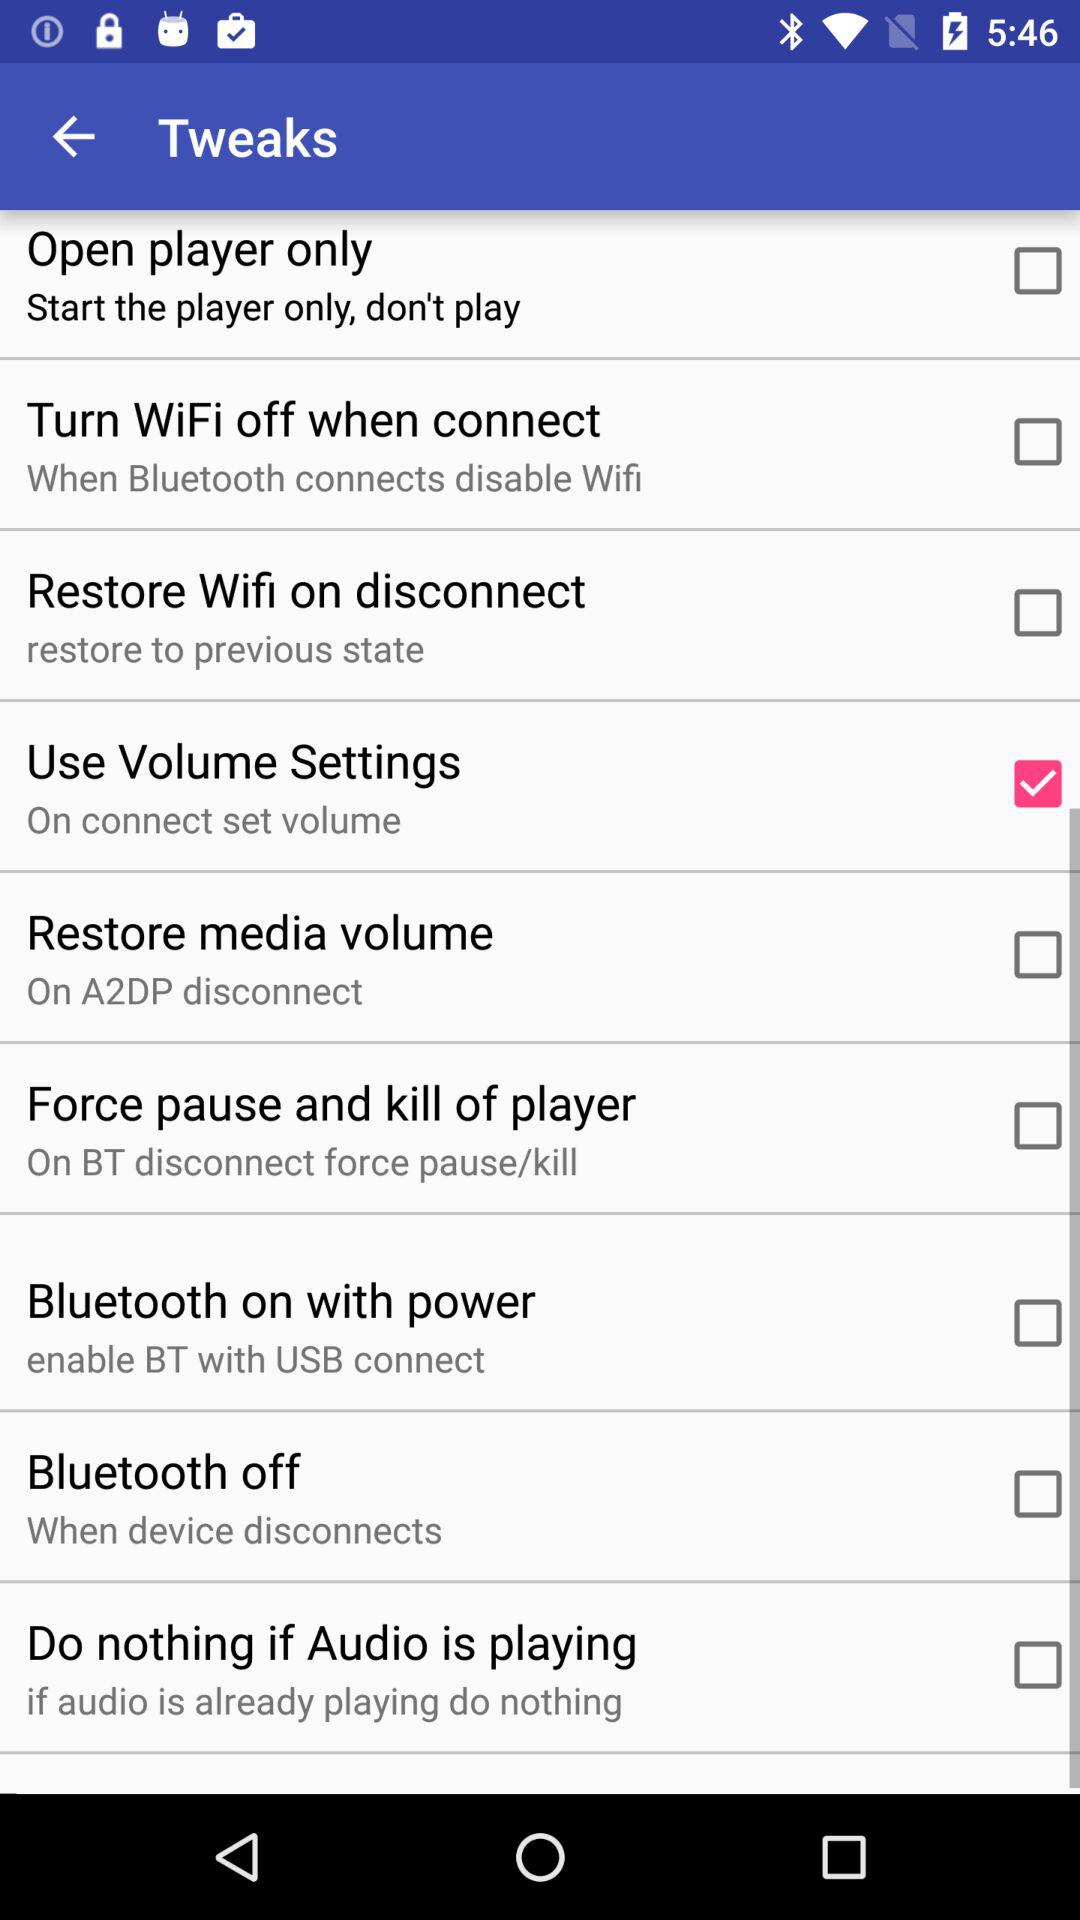What is the status of "Use Volume Settings"? The status is "on". 